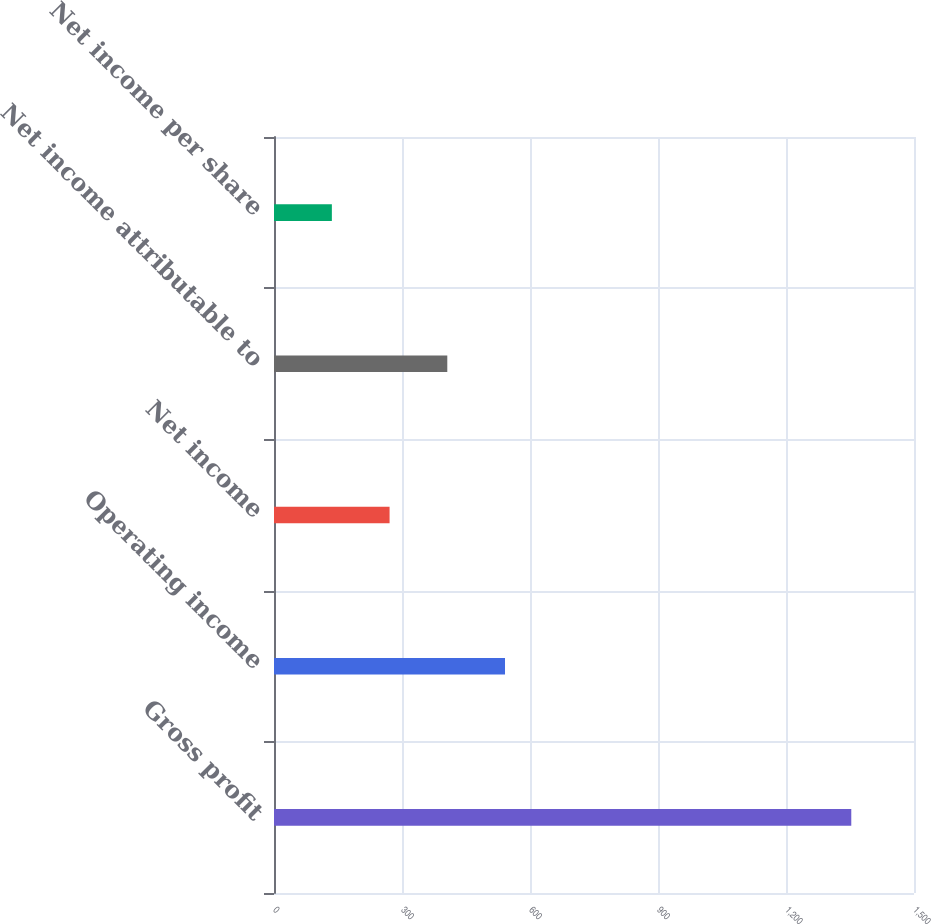Convert chart to OTSL. <chart><loc_0><loc_0><loc_500><loc_500><bar_chart><fcel>Gross profit<fcel>Operating income<fcel>Net income<fcel>Net income attributable to<fcel>Net income per share<nl><fcel>1353<fcel>541.42<fcel>270.88<fcel>406.15<fcel>135.61<nl></chart> 